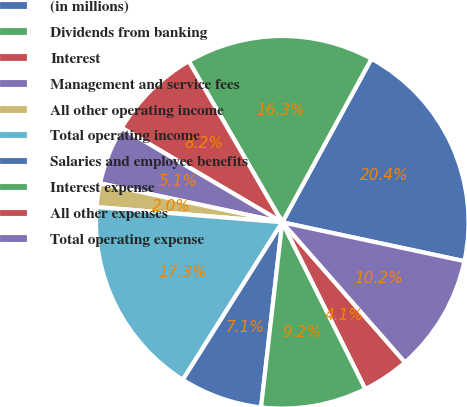<chart> <loc_0><loc_0><loc_500><loc_500><pie_chart><fcel>(in millions)<fcel>Dividends from banking<fcel>Interest<fcel>Management and service fees<fcel>All other operating income<fcel>Total operating income<fcel>Salaries and employee benefits<fcel>Interest expense<fcel>All other expenses<fcel>Total operating expense<nl><fcel>20.4%<fcel>16.32%<fcel>8.17%<fcel>5.11%<fcel>2.05%<fcel>17.34%<fcel>7.15%<fcel>9.18%<fcel>4.09%<fcel>10.2%<nl></chart> 